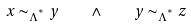Convert formula to latex. <formula><loc_0><loc_0><loc_500><loc_500>x \sim _ { \Lambda ^ { ^ { * } } } y \quad \land \quad y \sim _ { \Lambda ^ { ^ { * } } } z</formula> 